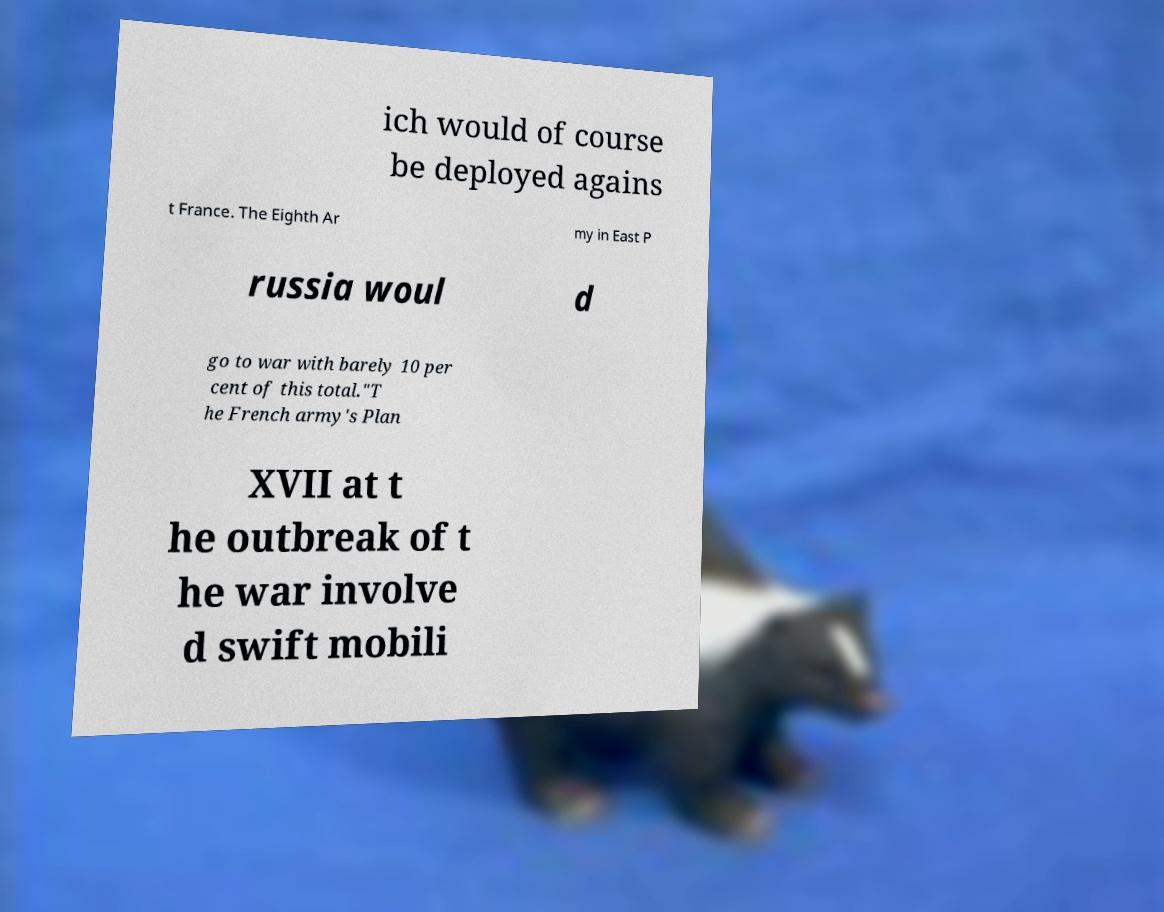Please identify and transcribe the text found in this image. ich would of course be deployed agains t France. The Eighth Ar my in East P russia woul d go to war with barely 10 per cent of this total."T he French army's Plan XVII at t he outbreak of t he war involve d swift mobili 